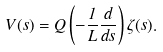Convert formula to latex. <formula><loc_0><loc_0><loc_500><loc_500>V ( s ) = Q \left ( - \frac { 1 } { L } \frac { d } { d s } \right ) \zeta ( s ) .</formula> 